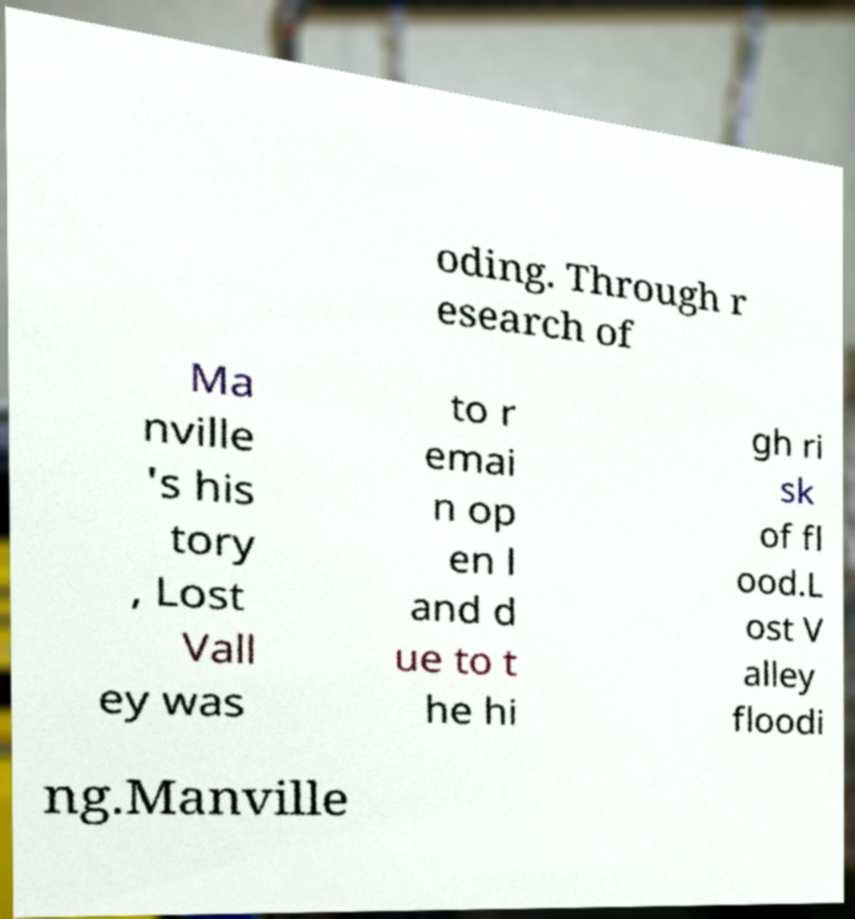Can you accurately transcribe the text from the provided image for me? oding. Through r esearch of Ma nville 's his tory , Lost Vall ey was to r emai n op en l and d ue to t he hi gh ri sk of fl ood.L ost V alley floodi ng.Manville 